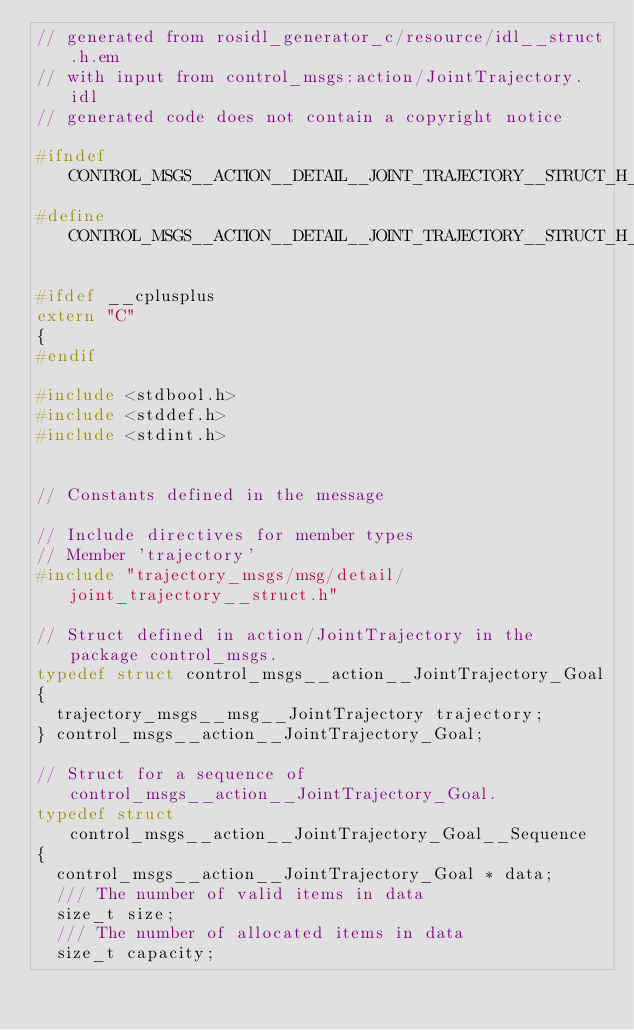<code> <loc_0><loc_0><loc_500><loc_500><_C_>// generated from rosidl_generator_c/resource/idl__struct.h.em
// with input from control_msgs:action/JointTrajectory.idl
// generated code does not contain a copyright notice

#ifndef CONTROL_MSGS__ACTION__DETAIL__JOINT_TRAJECTORY__STRUCT_H_
#define CONTROL_MSGS__ACTION__DETAIL__JOINT_TRAJECTORY__STRUCT_H_

#ifdef __cplusplus
extern "C"
{
#endif

#include <stdbool.h>
#include <stddef.h>
#include <stdint.h>


// Constants defined in the message

// Include directives for member types
// Member 'trajectory'
#include "trajectory_msgs/msg/detail/joint_trajectory__struct.h"

// Struct defined in action/JointTrajectory in the package control_msgs.
typedef struct control_msgs__action__JointTrajectory_Goal
{
  trajectory_msgs__msg__JointTrajectory trajectory;
} control_msgs__action__JointTrajectory_Goal;

// Struct for a sequence of control_msgs__action__JointTrajectory_Goal.
typedef struct control_msgs__action__JointTrajectory_Goal__Sequence
{
  control_msgs__action__JointTrajectory_Goal * data;
  /// The number of valid items in data
  size_t size;
  /// The number of allocated items in data
  size_t capacity;</code> 